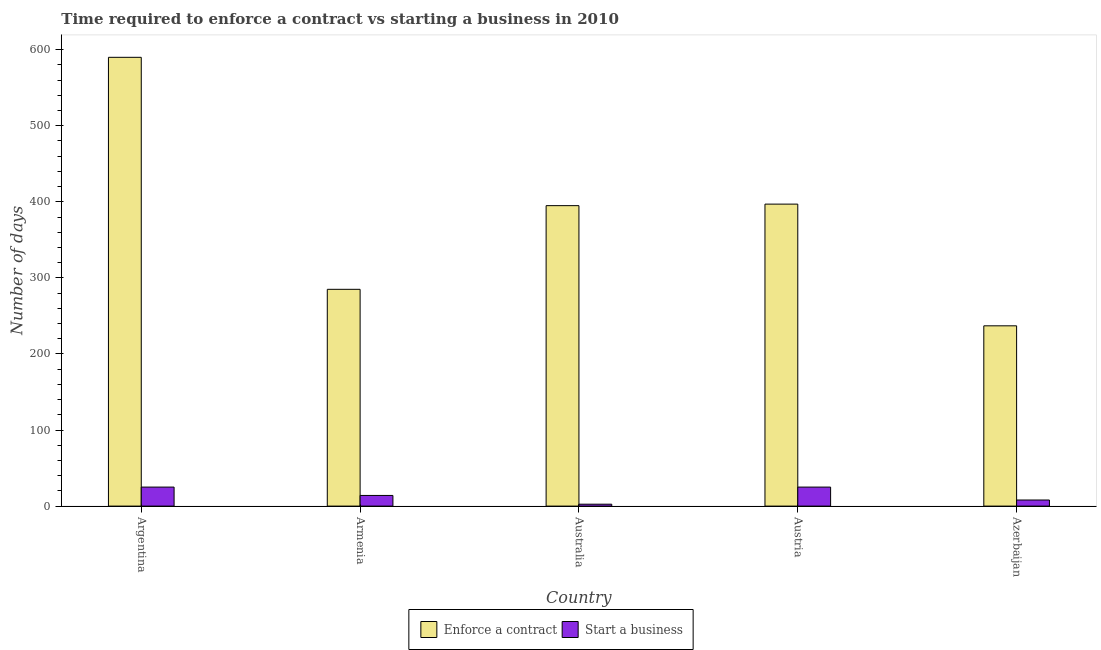How many different coloured bars are there?
Give a very brief answer. 2. How many groups of bars are there?
Provide a succinct answer. 5. Are the number of bars per tick equal to the number of legend labels?
Provide a succinct answer. Yes. How many bars are there on the 1st tick from the left?
Your response must be concise. 2. How many bars are there on the 4th tick from the right?
Provide a short and direct response. 2. What is the label of the 5th group of bars from the left?
Offer a terse response. Azerbaijan. In how many cases, is the number of bars for a given country not equal to the number of legend labels?
Make the answer very short. 0. What is the number of days to enforece a contract in Australia?
Provide a short and direct response. 395. Across all countries, what is the maximum number of days to enforece a contract?
Your answer should be compact. 590. Across all countries, what is the minimum number of days to start a business?
Your response must be concise. 2.5. In which country was the number of days to enforece a contract maximum?
Ensure brevity in your answer.  Argentina. In which country was the number of days to enforece a contract minimum?
Keep it short and to the point. Azerbaijan. What is the total number of days to enforece a contract in the graph?
Provide a succinct answer. 1904. What is the difference between the number of days to enforece a contract in Armenia and that in Australia?
Provide a short and direct response. -110. What is the difference between the number of days to start a business in Argentina and the number of days to enforece a contract in Austria?
Make the answer very short. -372. What is the average number of days to enforece a contract per country?
Your answer should be compact. 380.8. What is the difference between the number of days to enforece a contract and number of days to start a business in Argentina?
Your answer should be very brief. 565. What is the ratio of the number of days to start a business in Argentina to that in Austria?
Offer a very short reply. 1. Is the difference between the number of days to start a business in Australia and Azerbaijan greater than the difference between the number of days to enforece a contract in Australia and Azerbaijan?
Provide a short and direct response. No. What is the difference between the highest and the second highest number of days to enforece a contract?
Your answer should be compact. 193. What is the difference between the highest and the lowest number of days to start a business?
Offer a terse response. 22.5. What does the 2nd bar from the left in Azerbaijan represents?
Provide a succinct answer. Start a business. What does the 1st bar from the right in Azerbaijan represents?
Your answer should be compact. Start a business. How many bars are there?
Your answer should be compact. 10. How many countries are there in the graph?
Ensure brevity in your answer.  5. Are the values on the major ticks of Y-axis written in scientific E-notation?
Your answer should be compact. No. Does the graph contain any zero values?
Keep it short and to the point. No. Does the graph contain grids?
Ensure brevity in your answer.  No. Where does the legend appear in the graph?
Offer a very short reply. Bottom center. How many legend labels are there?
Ensure brevity in your answer.  2. What is the title of the graph?
Your answer should be compact. Time required to enforce a contract vs starting a business in 2010. What is the label or title of the X-axis?
Your answer should be compact. Country. What is the label or title of the Y-axis?
Provide a short and direct response. Number of days. What is the Number of days in Enforce a contract in Argentina?
Your response must be concise. 590. What is the Number of days of Start a business in Argentina?
Give a very brief answer. 25. What is the Number of days of Enforce a contract in Armenia?
Make the answer very short. 285. What is the Number of days in Enforce a contract in Australia?
Your answer should be compact. 395. What is the Number of days of Start a business in Australia?
Keep it short and to the point. 2.5. What is the Number of days of Enforce a contract in Austria?
Give a very brief answer. 397. What is the Number of days of Start a business in Austria?
Offer a terse response. 25. What is the Number of days of Enforce a contract in Azerbaijan?
Make the answer very short. 237. What is the Number of days of Start a business in Azerbaijan?
Provide a short and direct response. 8. Across all countries, what is the maximum Number of days of Enforce a contract?
Make the answer very short. 590. Across all countries, what is the minimum Number of days in Enforce a contract?
Keep it short and to the point. 237. What is the total Number of days of Enforce a contract in the graph?
Give a very brief answer. 1904. What is the total Number of days in Start a business in the graph?
Provide a short and direct response. 74.5. What is the difference between the Number of days of Enforce a contract in Argentina and that in Armenia?
Ensure brevity in your answer.  305. What is the difference between the Number of days in Start a business in Argentina and that in Armenia?
Provide a short and direct response. 11. What is the difference between the Number of days of Enforce a contract in Argentina and that in Australia?
Ensure brevity in your answer.  195. What is the difference between the Number of days in Start a business in Argentina and that in Australia?
Provide a succinct answer. 22.5. What is the difference between the Number of days in Enforce a contract in Argentina and that in Austria?
Give a very brief answer. 193. What is the difference between the Number of days of Start a business in Argentina and that in Austria?
Your answer should be very brief. 0. What is the difference between the Number of days of Enforce a contract in Argentina and that in Azerbaijan?
Your answer should be compact. 353. What is the difference between the Number of days in Enforce a contract in Armenia and that in Australia?
Provide a short and direct response. -110. What is the difference between the Number of days of Enforce a contract in Armenia and that in Austria?
Make the answer very short. -112. What is the difference between the Number of days in Start a business in Armenia and that in Austria?
Keep it short and to the point. -11. What is the difference between the Number of days of Start a business in Australia and that in Austria?
Your answer should be compact. -22.5. What is the difference between the Number of days of Enforce a contract in Australia and that in Azerbaijan?
Give a very brief answer. 158. What is the difference between the Number of days in Enforce a contract in Austria and that in Azerbaijan?
Offer a very short reply. 160. What is the difference between the Number of days of Start a business in Austria and that in Azerbaijan?
Your response must be concise. 17. What is the difference between the Number of days in Enforce a contract in Argentina and the Number of days in Start a business in Armenia?
Give a very brief answer. 576. What is the difference between the Number of days of Enforce a contract in Argentina and the Number of days of Start a business in Australia?
Make the answer very short. 587.5. What is the difference between the Number of days in Enforce a contract in Argentina and the Number of days in Start a business in Austria?
Offer a terse response. 565. What is the difference between the Number of days in Enforce a contract in Argentina and the Number of days in Start a business in Azerbaijan?
Keep it short and to the point. 582. What is the difference between the Number of days of Enforce a contract in Armenia and the Number of days of Start a business in Australia?
Provide a succinct answer. 282.5. What is the difference between the Number of days of Enforce a contract in Armenia and the Number of days of Start a business in Austria?
Your answer should be compact. 260. What is the difference between the Number of days of Enforce a contract in Armenia and the Number of days of Start a business in Azerbaijan?
Offer a very short reply. 277. What is the difference between the Number of days in Enforce a contract in Australia and the Number of days in Start a business in Austria?
Ensure brevity in your answer.  370. What is the difference between the Number of days in Enforce a contract in Australia and the Number of days in Start a business in Azerbaijan?
Your answer should be compact. 387. What is the difference between the Number of days of Enforce a contract in Austria and the Number of days of Start a business in Azerbaijan?
Your answer should be compact. 389. What is the average Number of days in Enforce a contract per country?
Provide a short and direct response. 380.8. What is the difference between the Number of days in Enforce a contract and Number of days in Start a business in Argentina?
Offer a very short reply. 565. What is the difference between the Number of days of Enforce a contract and Number of days of Start a business in Armenia?
Your answer should be very brief. 271. What is the difference between the Number of days of Enforce a contract and Number of days of Start a business in Australia?
Keep it short and to the point. 392.5. What is the difference between the Number of days of Enforce a contract and Number of days of Start a business in Austria?
Offer a very short reply. 372. What is the difference between the Number of days of Enforce a contract and Number of days of Start a business in Azerbaijan?
Your answer should be very brief. 229. What is the ratio of the Number of days of Enforce a contract in Argentina to that in Armenia?
Your answer should be very brief. 2.07. What is the ratio of the Number of days of Start a business in Argentina to that in Armenia?
Give a very brief answer. 1.79. What is the ratio of the Number of days of Enforce a contract in Argentina to that in Australia?
Ensure brevity in your answer.  1.49. What is the ratio of the Number of days in Start a business in Argentina to that in Australia?
Provide a succinct answer. 10. What is the ratio of the Number of days of Enforce a contract in Argentina to that in Austria?
Provide a succinct answer. 1.49. What is the ratio of the Number of days in Start a business in Argentina to that in Austria?
Make the answer very short. 1. What is the ratio of the Number of days in Enforce a contract in Argentina to that in Azerbaijan?
Your response must be concise. 2.49. What is the ratio of the Number of days of Start a business in Argentina to that in Azerbaijan?
Your answer should be very brief. 3.12. What is the ratio of the Number of days in Enforce a contract in Armenia to that in Australia?
Your answer should be compact. 0.72. What is the ratio of the Number of days of Start a business in Armenia to that in Australia?
Make the answer very short. 5.6. What is the ratio of the Number of days of Enforce a contract in Armenia to that in Austria?
Your answer should be compact. 0.72. What is the ratio of the Number of days in Start a business in Armenia to that in Austria?
Keep it short and to the point. 0.56. What is the ratio of the Number of days in Enforce a contract in Armenia to that in Azerbaijan?
Your answer should be very brief. 1.2. What is the ratio of the Number of days of Start a business in Armenia to that in Azerbaijan?
Offer a terse response. 1.75. What is the ratio of the Number of days in Start a business in Australia to that in Azerbaijan?
Offer a terse response. 0.31. What is the ratio of the Number of days in Enforce a contract in Austria to that in Azerbaijan?
Ensure brevity in your answer.  1.68. What is the ratio of the Number of days in Start a business in Austria to that in Azerbaijan?
Provide a succinct answer. 3.12. What is the difference between the highest and the second highest Number of days of Enforce a contract?
Make the answer very short. 193. What is the difference between the highest and the lowest Number of days in Enforce a contract?
Provide a short and direct response. 353. 